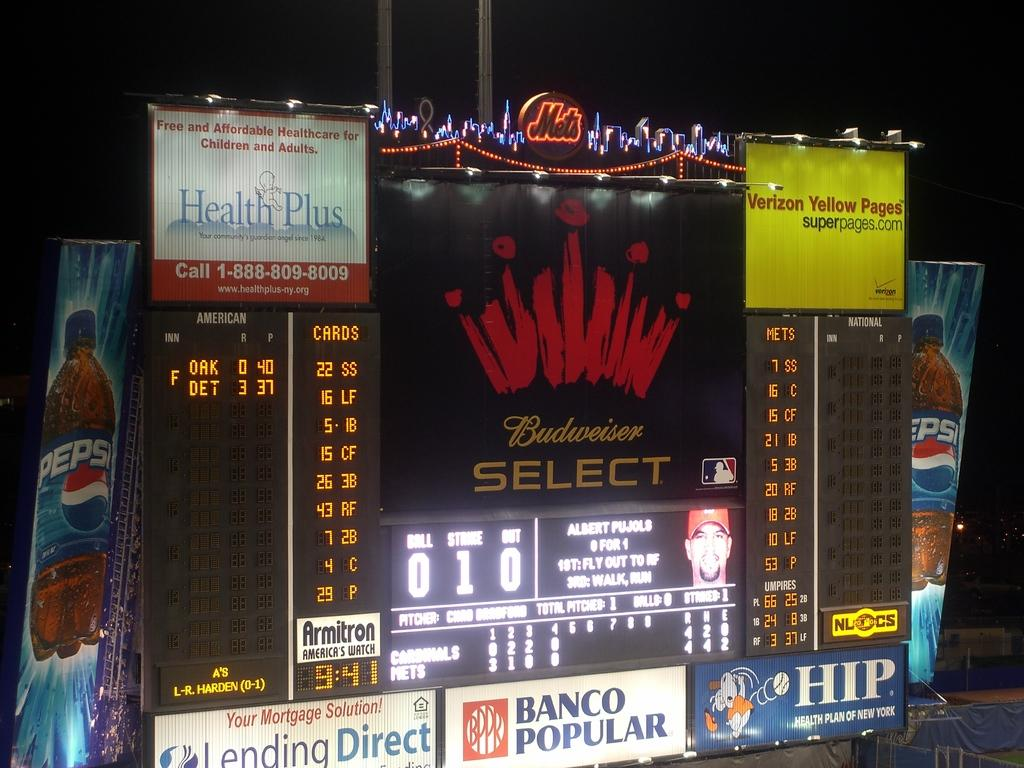<image>
Provide a brief description of the given image. Score board featuring Budweiser Select, Lending Direct, Pepsi Verizon Yellow Pages, and HIP. 